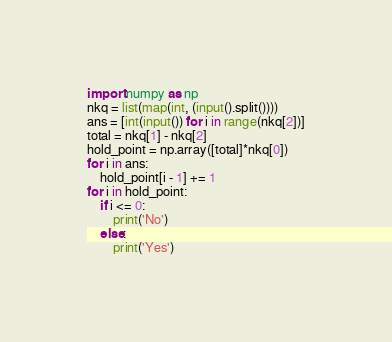<code> <loc_0><loc_0><loc_500><loc_500><_Python_>import numpy as np
nkq = list(map(int, (input().split())))
ans = [int(input()) for i in range(nkq[2])]
total = nkq[1] - nkq[2]
hold_point = np.array([total]*nkq[0])
for i in ans:
    hold_point[i - 1] += 1
for i in hold_point:
    if i <= 0:
        print('No')
    else:
        print('Yes')</code> 